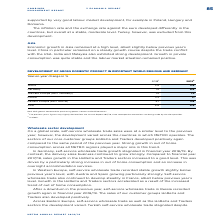According to Metro Ag's financial document, Why might the figures in this annual report deviate slightly from last year? since retrospective corrections are being made by the data provider. The document states: "slightly deviate from the Annual Report 2017/18, since retrospective corrections are being made by the data provider...." Also, What is the year-on-year change in GDP in Asia in 2019? According to the financial document, 4.9 (percentage). The relevant text states: "Asia 5.6 4.9..." Also, Which regions in the table are listed in the analysis of GDP? The document contains multiple relevant values: World, Germany, Western Europe (excl.Germany), Russia, Eastern Europe (excl.Russia), Asia. From the document: "Asia 5.6 4.9 World 3.6 2.9..." Additionally, In which year was the Year-on-year percentage change of GDP in Asia larger from 2018 to 2019? According to the financial document, 2018. The relevant text states: "2018 1 2019 2..." Also, can you calculate: What was the change in the year-on-year percentage change in GDP for Russia from 2018 to 2019? Based on the calculation: 1.1-2.3, the result is -1.2 (percentage). This is based on the information: "Russia 2.3 1.1 Russia 2.3 1.1..." The key data points involved are: 1.1, 2.3. Also, can you calculate: What was the change in the year-on-year percentage change in GDP for Germany from 2018 to 2019? Based on the calculation: 0.6-1.5, the result is -0.9 (percentage). This is based on the information: "Germany 1.5 0.6 Germany 1.5 0.6..." The key data points involved are: 0.6, 1.5. 